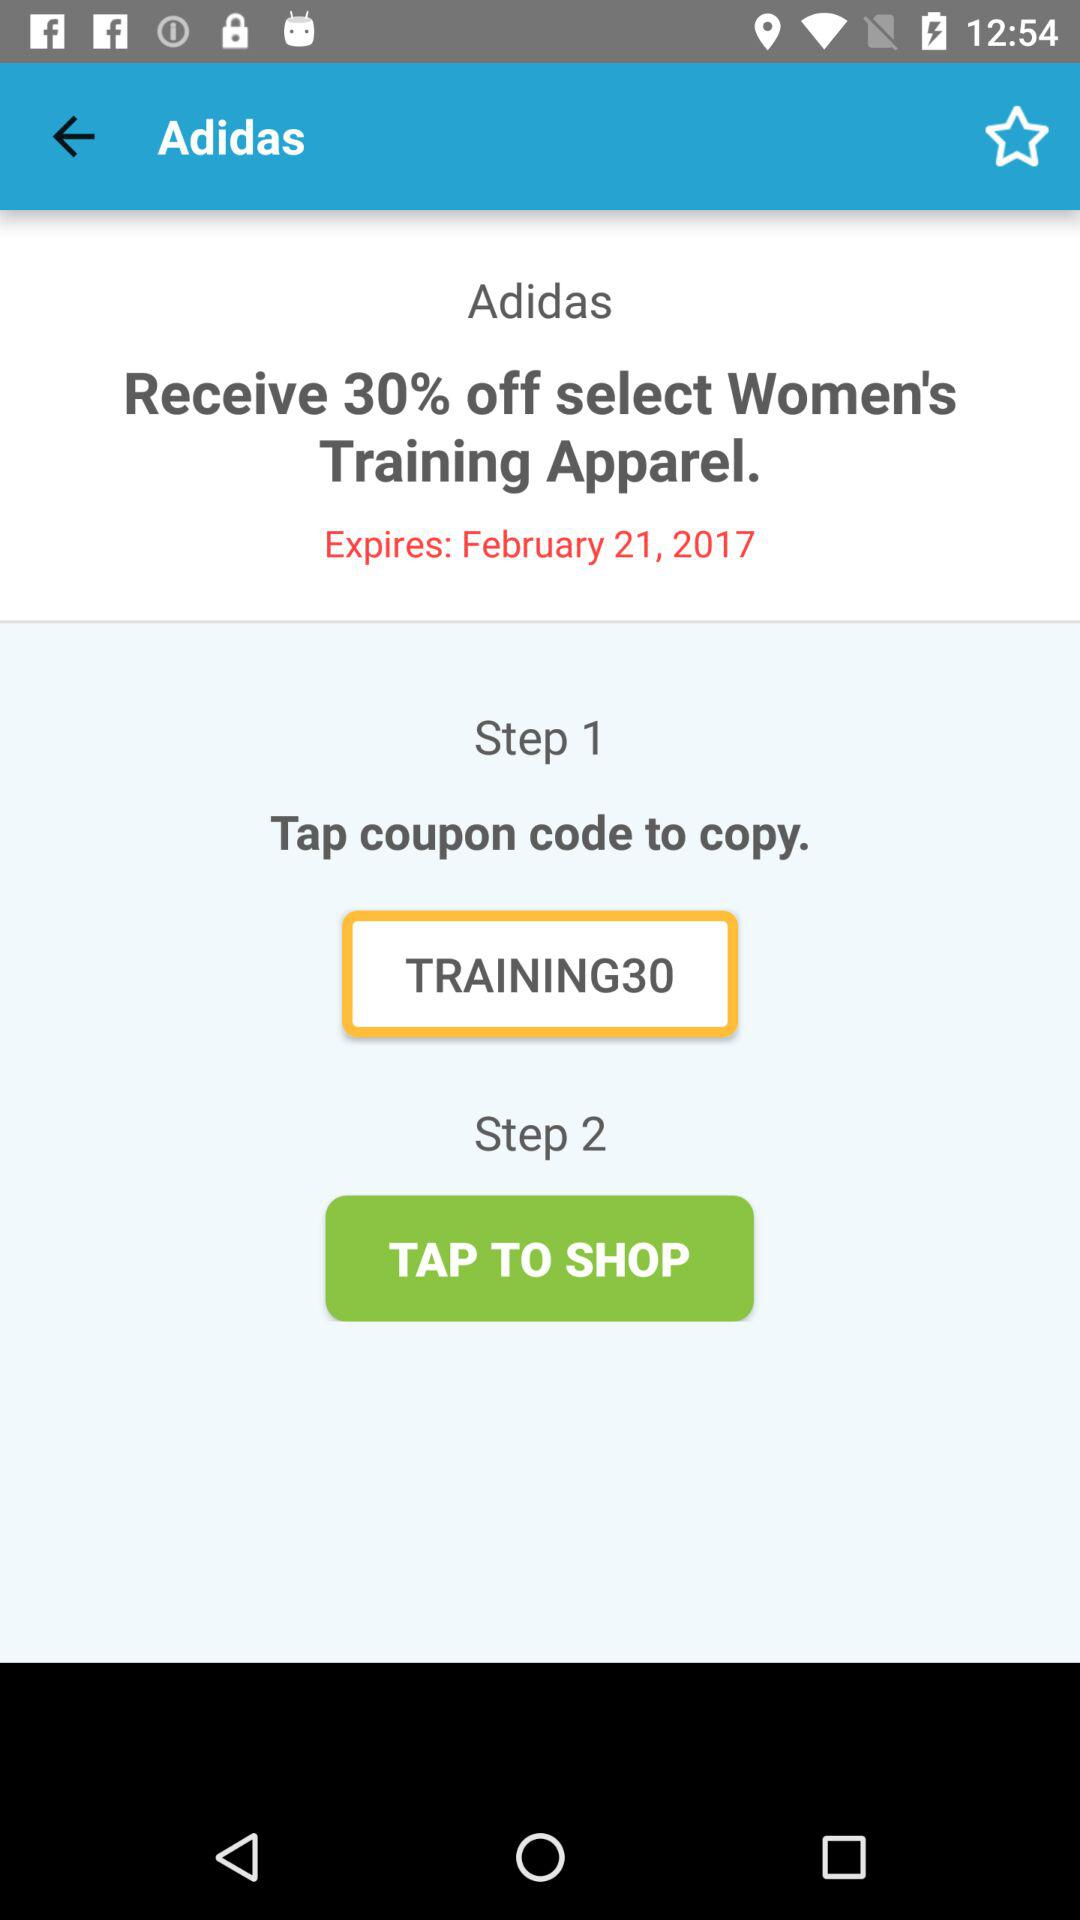On what date will the discount expire? The discount will expire on February 21, 2017. 